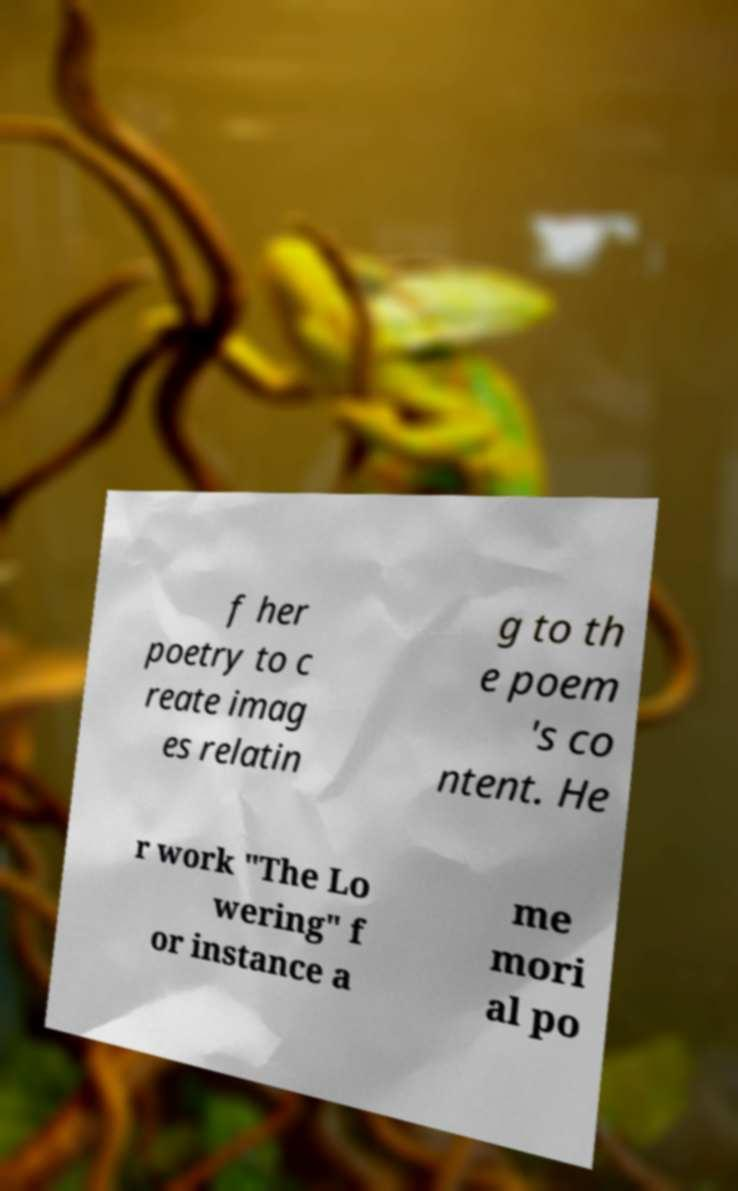Please identify and transcribe the text found in this image. f her poetry to c reate imag es relatin g to th e poem 's co ntent. He r work "The Lo wering" f or instance a me mori al po 